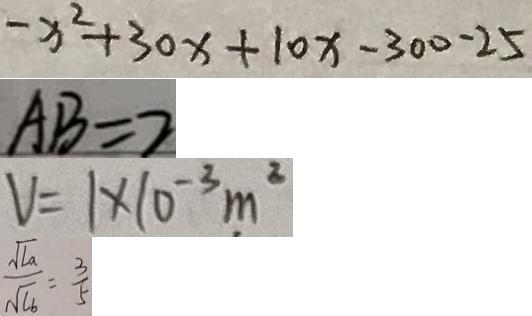<formula> <loc_0><loc_0><loc_500><loc_500>- x ^ { 2 } + 3 0 x + 1 0 x - 3 0 0 - 2 5 
 A B = 2 
 V = 1 \times 1 0 ^ { - 3 } m ^ { 2 } 
 \frac { \sqrt { l a } } { \sqrt { l b } } = \frac { 3 } { 5 }</formula> 